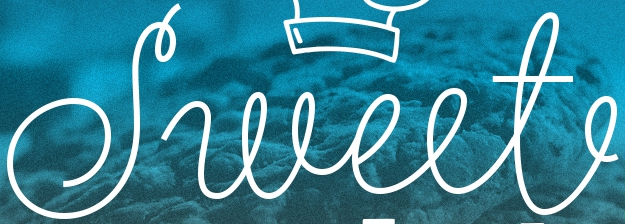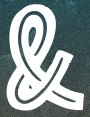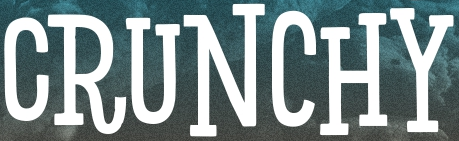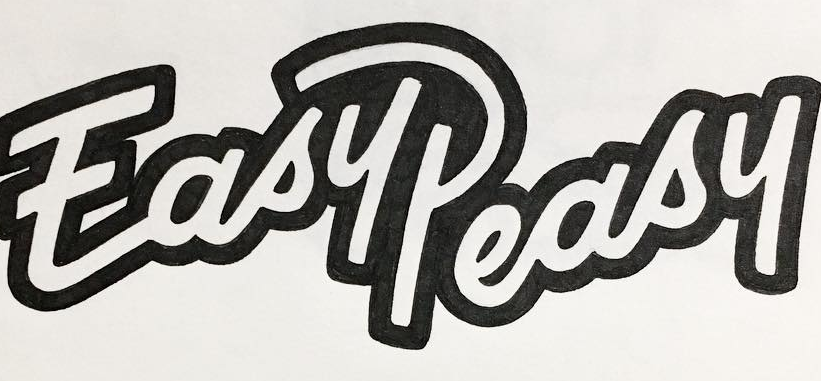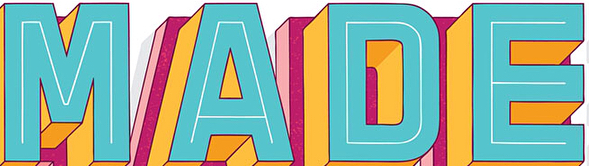Transcribe the words shown in these images in order, separated by a semicolon. Sweet; &; CRUNCHY; EasyPeasy; MADE 